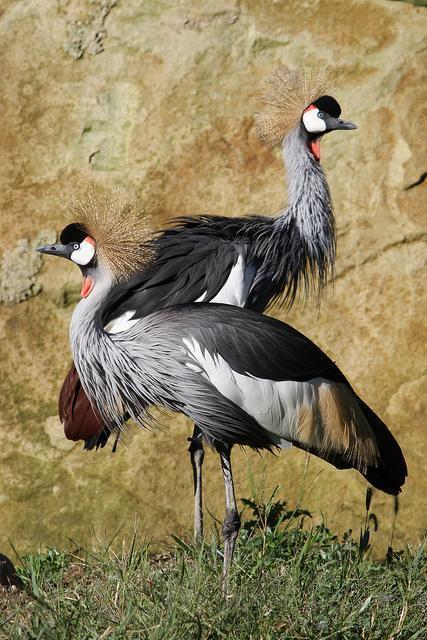How many birds are visible?
Give a very brief answer. 2. How many types of cakes are here?
Give a very brief answer. 0. 